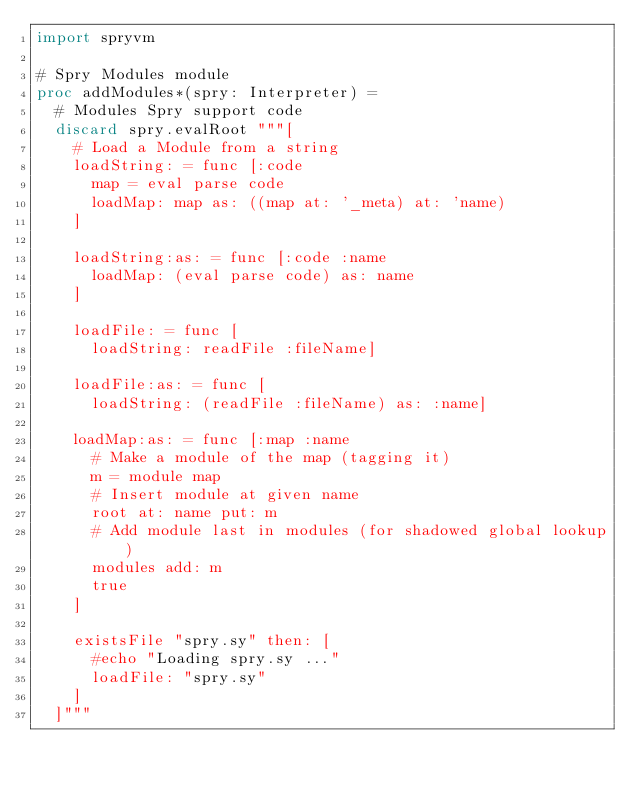<code> <loc_0><loc_0><loc_500><loc_500><_Nim_>import spryvm

# Spry Modules module
proc addModules*(spry: Interpreter) =
  # Modules Spry support code
  discard spry.evalRoot """[
    # Load a Module from a string
    loadString: = func [:code
      map = eval parse code
      loadMap: map as: ((map at: '_meta) at: 'name)
    ]

    loadString:as: = func [:code :name
      loadMap: (eval parse code) as: name
    ]

    loadFile: = func [
      loadString: readFile :fileName]

    loadFile:as: = func [
      loadString: (readFile :fileName) as: :name]

    loadMap:as: = func [:map :name
      # Make a module of the map (tagging it)
      m = module map
      # Insert module at given name
      root at: name put: m
      # Add module last in modules (for shadowed global lookup)
      modules add: m
      true
    ]

    existsFile "spry.sy" then: [
      #echo "Loading spry.sy ..."
      loadFile: "spry.sy"
    ]
  ]"""

</code> 